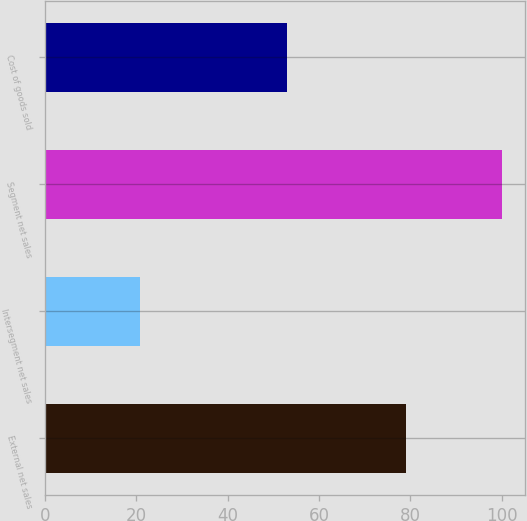Convert chart. <chart><loc_0><loc_0><loc_500><loc_500><bar_chart><fcel>External net sales<fcel>Intersegment net sales<fcel>Segment net sales<fcel>Cost of goods sold<nl><fcel>79.1<fcel>20.9<fcel>100<fcel>52.9<nl></chart> 